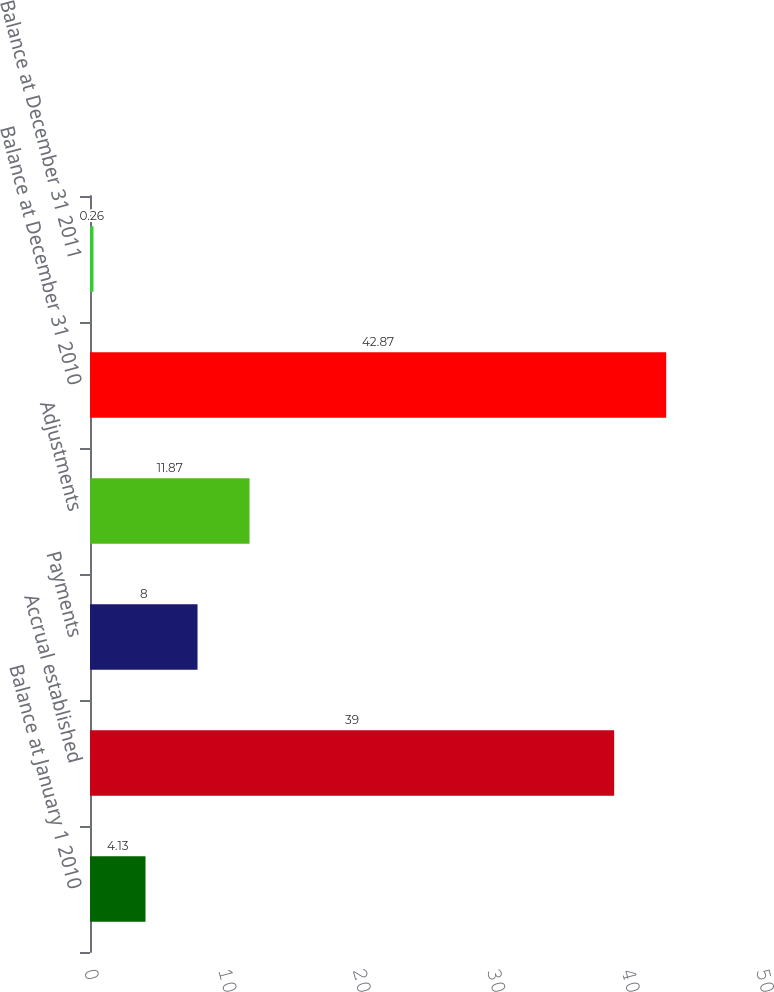<chart> <loc_0><loc_0><loc_500><loc_500><bar_chart><fcel>Balance at January 1 2010<fcel>Accrual established<fcel>Payments<fcel>Adjustments<fcel>Balance at December 31 2010<fcel>Balance at December 31 2011<nl><fcel>4.13<fcel>39<fcel>8<fcel>11.87<fcel>42.87<fcel>0.26<nl></chart> 